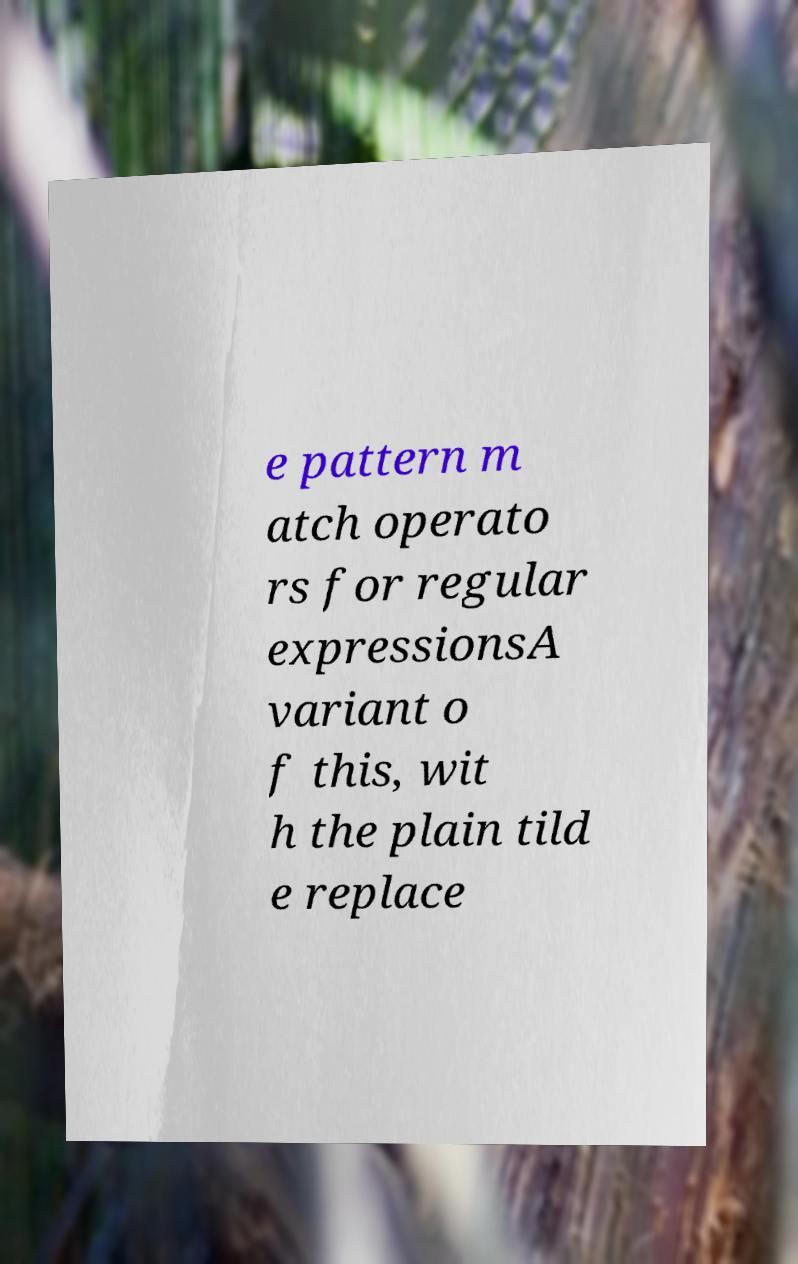Could you extract and type out the text from this image? e pattern m atch operato rs for regular expressionsA variant o f this, wit h the plain tild e replace 